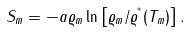Convert formula to latex. <formula><loc_0><loc_0><loc_500><loc_500>S _ { m } = - a \varrho _ { m } \ln \left [ \varrho _ { m } / \varrho ^ { ^ { * } } ( T _ { m } ) \right ] .</formula> 